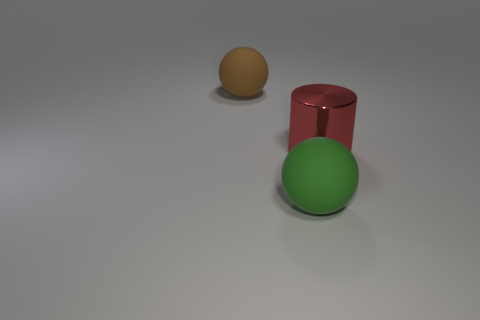Add 1 large red matte balls. How many objects exist? 4 Subtract 0 cyan spheres. How many objects are left? 3 Subtract all spheres. How many objects are left? 1 Subtract 2 spheres. How many spheres are left? 0 Subtract all blue cylinders. Subtract all brown balls. How many cylinders are left? 1 Subtract all yellow cylinders. How many blue balls are left? 0 Subtract all big cyan metallic spheres. Subtract all big red objects. How many objects are left? 2 Add 2 big brown spheres. How many big brown spheres are left? 3 Add 2 matte balls. How many matte balls exist? 4 Subtract all green spheres. How many spheres are left? 1 